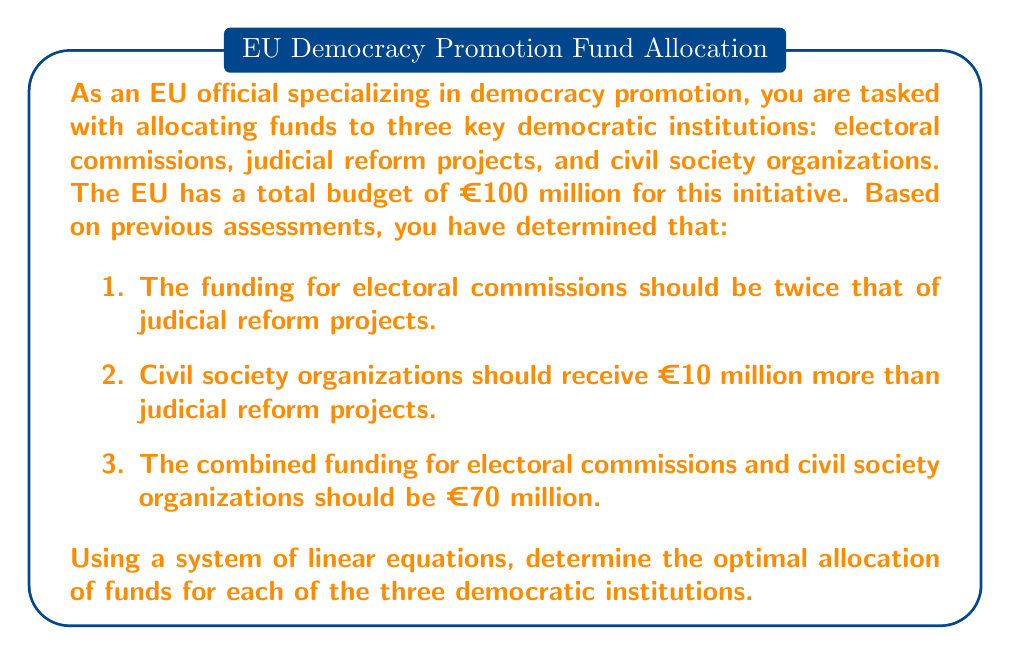Show me your answer to this math problem. Let's define our variables:
$x$ = funding for judicial reform projects
$y$ = funding for electoral commissions
$z$ = funding for civil society organizations

Now, we can set up our system of equations based on the given information:

1. $y = 2x$ (electoral commissions receive twice the funding of judicial reform)
2. $z = x + 10$ (civil society organizations receive €10 million more than judicial reform)
3. $y + z = 70$ (combined funding for electoral commissions and civil society organizations is €70 million)
4. $x + y + z = 100$ (total budget is €100 million)

Let's solve this system step by step:

Step 1: Substitute equation 1 into equation 3
$2x + z = 70$

Step 2: Substitute equation 2 into the result from Step 1
$2x + (x + 10) = 70$
$3x + 10 = 70$
$3x = 60$
$x = 20$

Step 3: Use the value of $x$ to find $y$ and $z$
$y = 2x = 2(20) = 40$
$z = x + 10 = 20 + 10 = 30$

Step 4: Verify that the total equals €100 million
$x + y + z = 20 + 40 + 30 = 100$

Therefore, the optimal allocation is:
Judicial reform projects: €20 million
Electoral commissions: €40 million
Civil society organizations: €30 million
Answer: The optimal allocation of EU funding for democratic institutions is:
Judicial reform projects: €20 million
Electoral commissions: €40 million
Civil society organizations: €30 million 